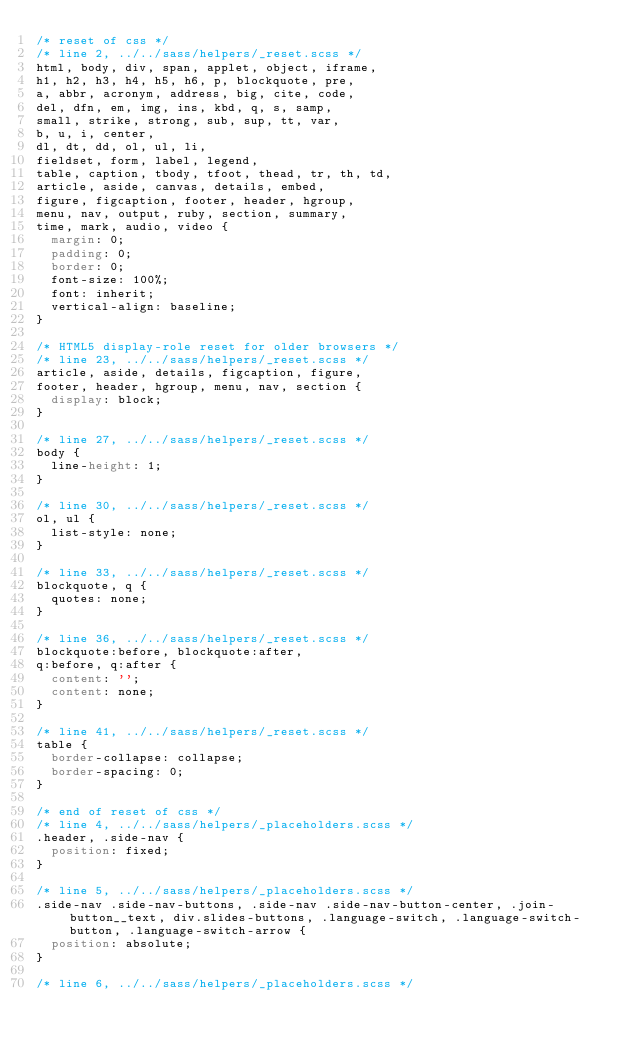Convert code to text. <code><loc_0><loc_0><loc_500><loc_500><_CSS_>/* reset of css */
/* line 2, ../../sass/helpers/_reset.scss */
html, body, div, span, applet, object, iframe,
h1, h2, h3, h4, h5, h6, p, blockquote, pre,
a, abbr, acronym, address, big, cite, code,
del, dfn, em, img, ins, kbd, q, s, samp,
small, strike, strong, sub, sup, tt, var,
b, u, i, center,
dl, dt, dd, ol, ul, li,
fieldset, form, label, legend,
table, caption, tbody, tfoot, thead, tr, th, td,
article, aside, canvas, details, embed,
figure, figcaption, footer, header, hgroup,
menu, nav, output, ruby, section, summary,
time, mark, audio, video {
  margin: 0;
  padding: 0;
  border: 0;
  font-size: 100%;
  font: inherit;
  vertical-align: baseline;
}

/* HTML5 display-role reset for older browsers */
/* line 23, ../../sass/helpers/_reset.scss */
article, aside, details, figcaption, figure,
footer, header, hgroup, menu, nav, section {
  display: block;
}

/* line 27, ../../sass/helpers/_reset.scss */
body {
  line-height: 1;
}

/* line 30, ../../sass/helpers/_reset.scss */
ol, ul {
  list-style: none;
}

/* line 33, ../../sass/helpers/_reset.scss */
blockquote, q {
  quotes: none;
}

/* line 36, ../../sass/helpers/_reset.scss */
blockquote:before, blockquote:after,
q:before, q:after {
  content: '';
  content: none;
}

/* line 41, ../../sass/helpers/_reset.scss */
table {
  border-collapse: collapse;
  border-spacing: 0;
}

/* end of reset of css */
/* line 4, ../../sass/helpers/_placeholders.scss */
.header, .side-nav {
  position: fixed;
}

/* line 5, ../../sass/helpers/_placeholders.scss */
.side-nav .side-nav-buttons, .side-nav .side-nav-button-center, .join-button__text, div.slides-buttons, .language-switch, .language-switch-button, .language-switch-arrow {
  position: absolute;
}

/* line 6, ../../sass/helpers/_placeholders.scss */</code> 